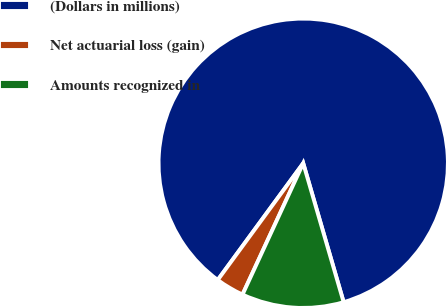Convert chart to OTSL. <chart><loc_0><loc_0><loc_500><loc_500><pie_chart><fcel>(Dollars in millions)<fcel>Net actuarial loss (gain)<fcel>Amounts recognized in<nl><fcel>85.43%<fcel>3.17%<fcel>11.4%<nl></chart> 